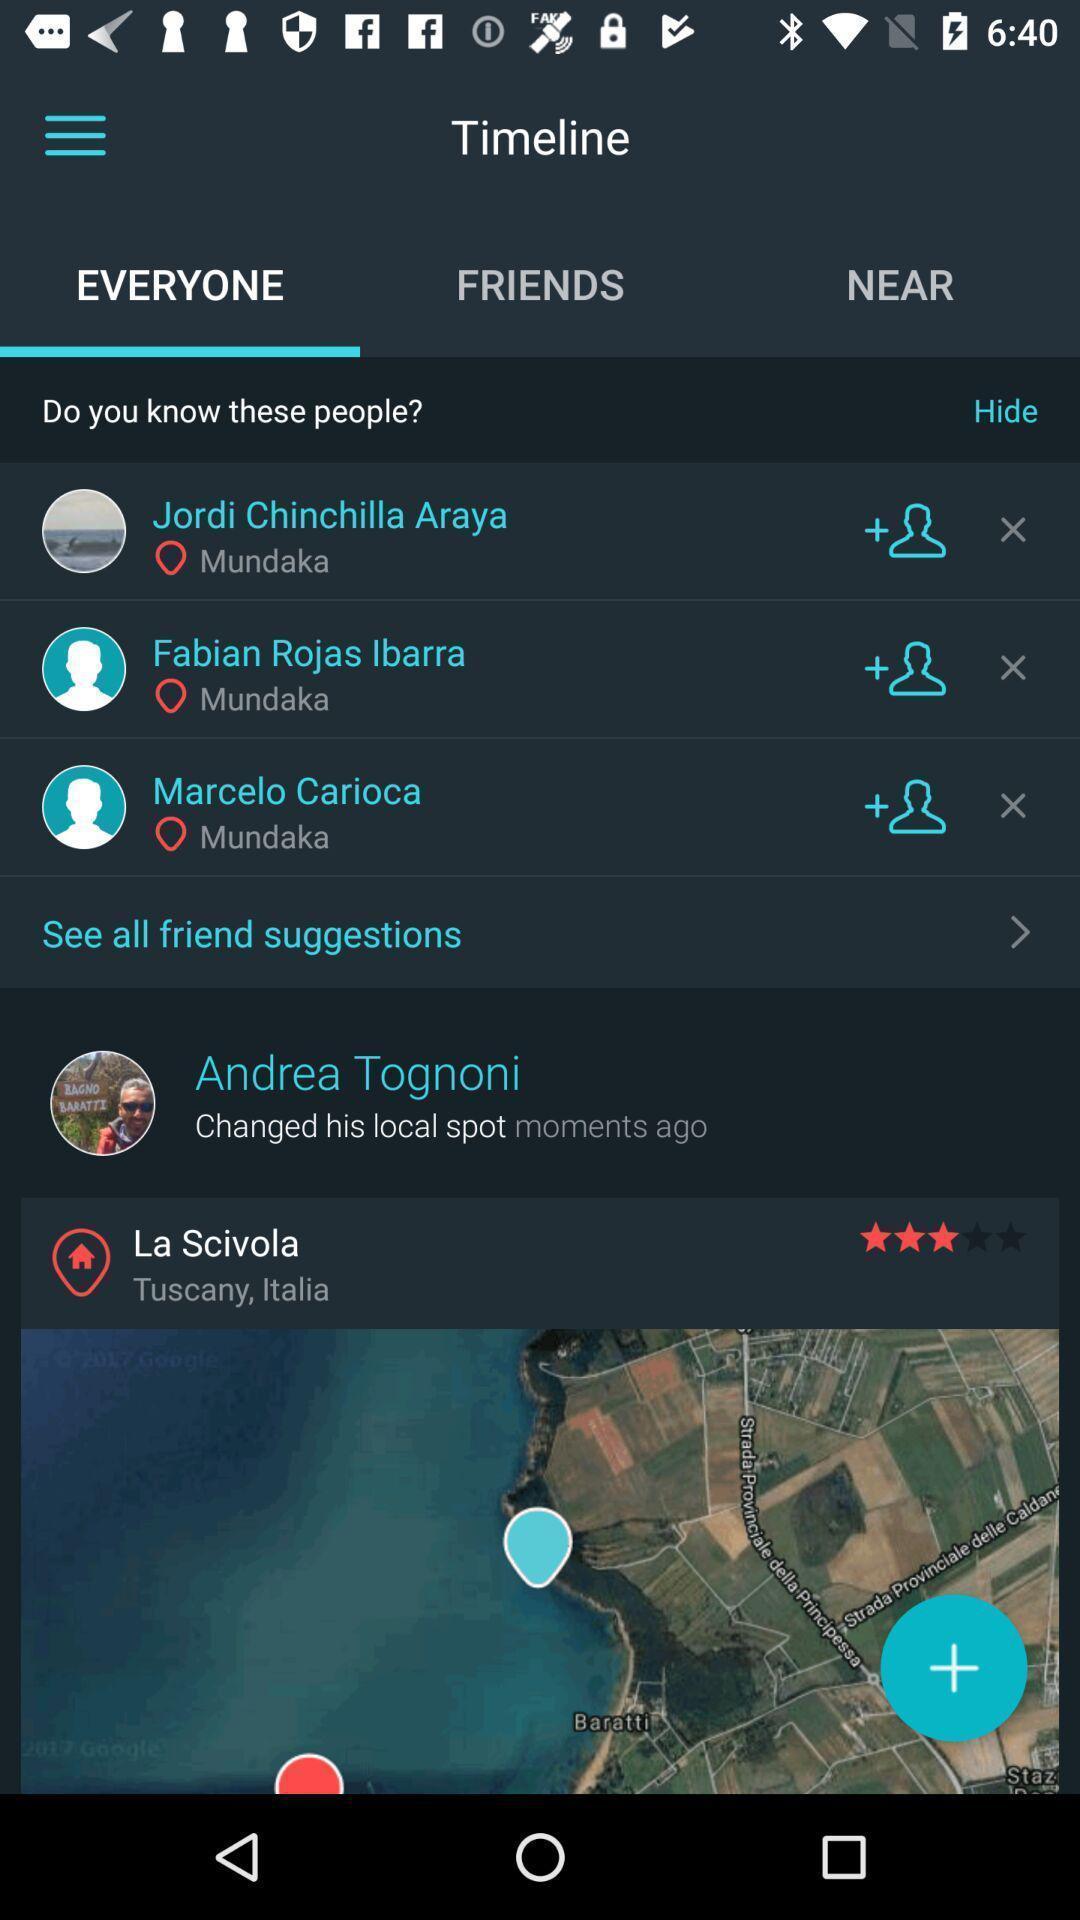Describe this image in words. Screen showing everyone 's timeline in a glassy app. 